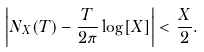<formula> <loc_0><loc_0><loc_500><loc_500>\left | N _ { X } ( T ) - \frac { T } { 2 \pi } \log [ X ] \right | < \frac { X } { 2 } .</formula> 